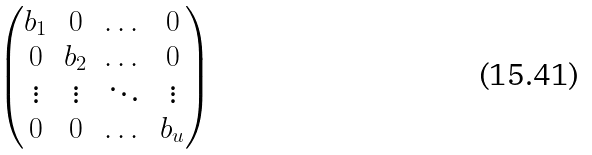<formula> <loc_0><loc_0><loc_500><loc_500>\begin{pmatrix} b _ { 1 } & 0 & \dots & 0 \\ 0 & b _ { 2 } & \dots & 0 \\ \vdots & \vdots & \ddots & \vdots \\ 0 & 0 & \dots & b _ { u } \end{pmatrix}</formula> 